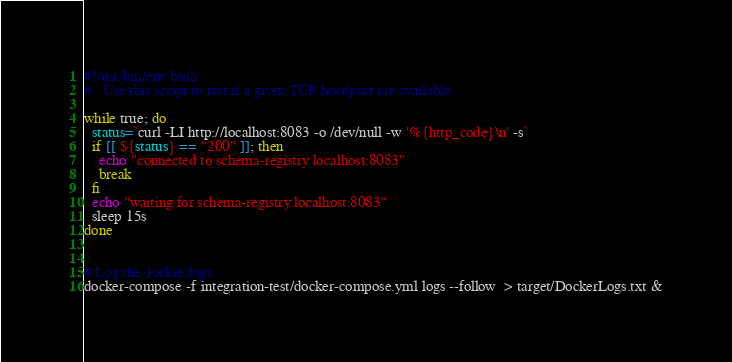<code> <loc_0><loc_0><loc_500><loc_500><_Bash_>#!/usr/bin/env bash
#   Use this script to test if a given TCP host/port are available

while true; do
  status=`curl -LI http://localhost:8083 -o /dev/null -w '%{http_code}\n' -s`
  if [[ ${status} == "200" ]]; then
    echo "connected to schema-registry localhost:8083"
    break
  fi
  echo "waiting for schema-registry localhost:8083"
  sleep 15s
done


# Log the docker logs
docker-compose -f integration-test/docker-compose.yml logs --follow  > target/DockerLogs.txt &
</code> 